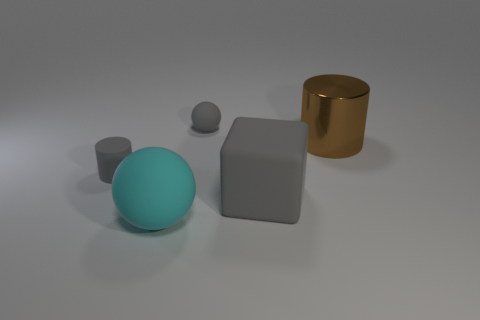Is the gray cylinder made of the same material as the big gray cube?
Offer a very short reply. Yes. What material is the brown thing that is the same size as the block?
Your response must be concise. Metal. How many things are either rubber things that are left of the small rubber ball or gray blocks?
Ensure brevity in your answer.  3. Are there an equal number of blocks in front of the large gray cube and large brown shiny cylinders?
Offer a very short reply. No. Is the big shiny cylinder the same color as the small cylinder?
Offer a very short reply. No. What is the color of the matte object that is both in front of the tiny matte cylinder and behind the big cyan rubber ball?
Provide a short and direct response. Gray. How many cylinders are big things or large brown things?
Your response must be concise. 1. Are there fewer large brown cylinders to the left of the big shiny thing than small red rubber cubes?
Your answer should be very brief. No. There is a big gray thing that is made of the same material as the small gray sphere; what is its shape?
Offer a very short reply. Cube. What number of small balls have the same color as the shiny cylinder?
Offer a very short reply. 0. 